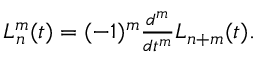<formula> <loc_0><loc_0><loc_500><loc_500>\begin{array} { r } { L _ { n } ^ { m } ( t ) = ( - 1 ) ^ { m } \frac { d ^ { m } } { d t ^ { m } } L _ { n + m } ( t ) . } \end{array}</formula> 